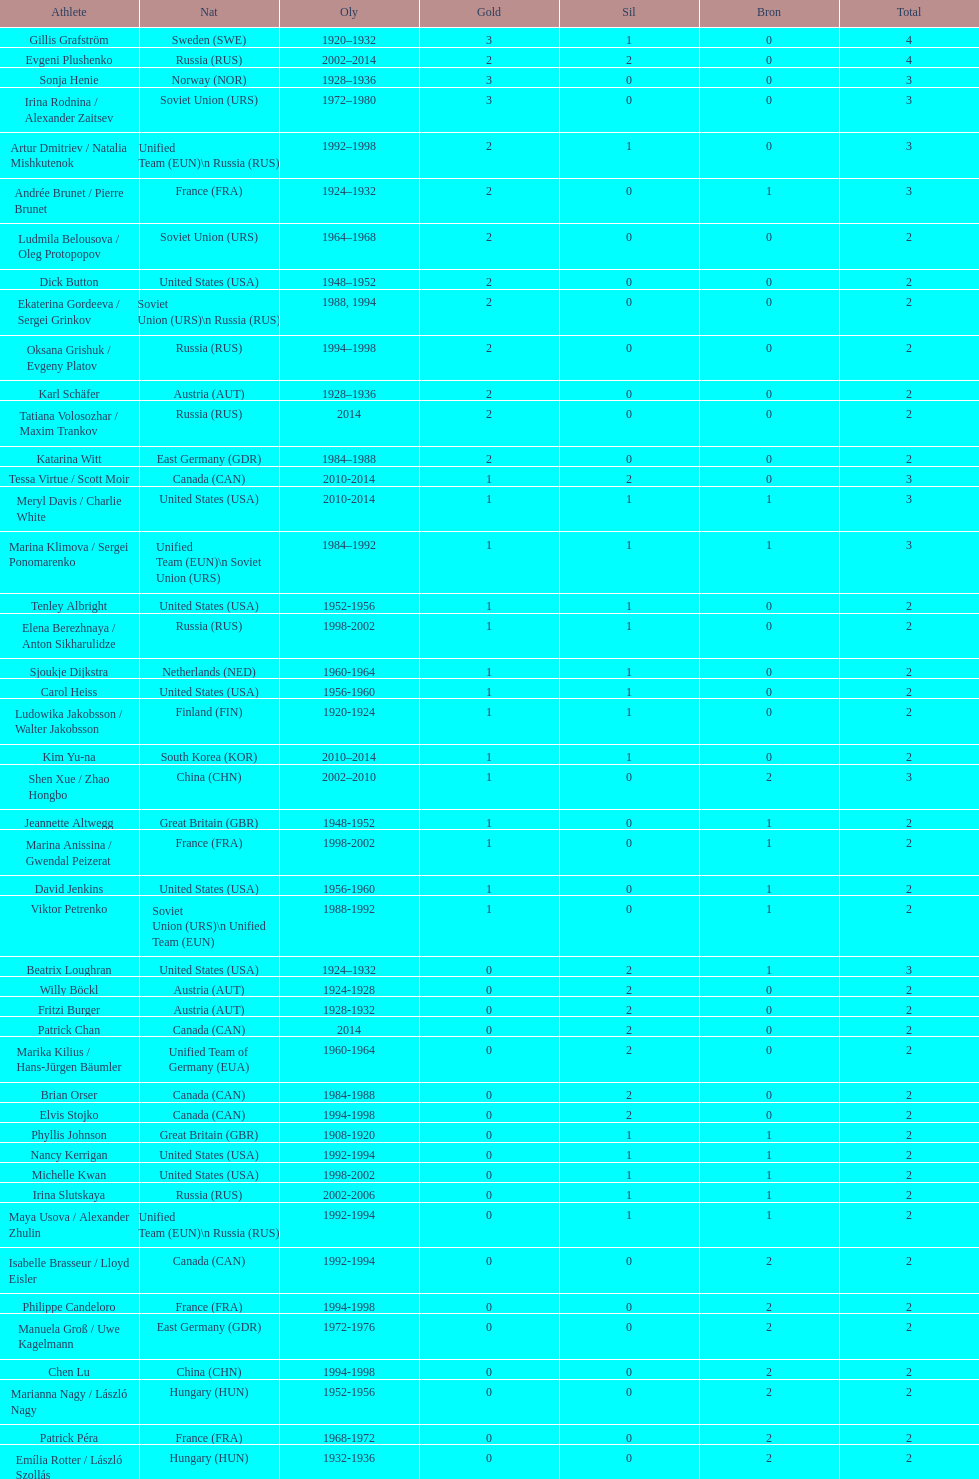How many medals have sweden and norway won combined? 7. 